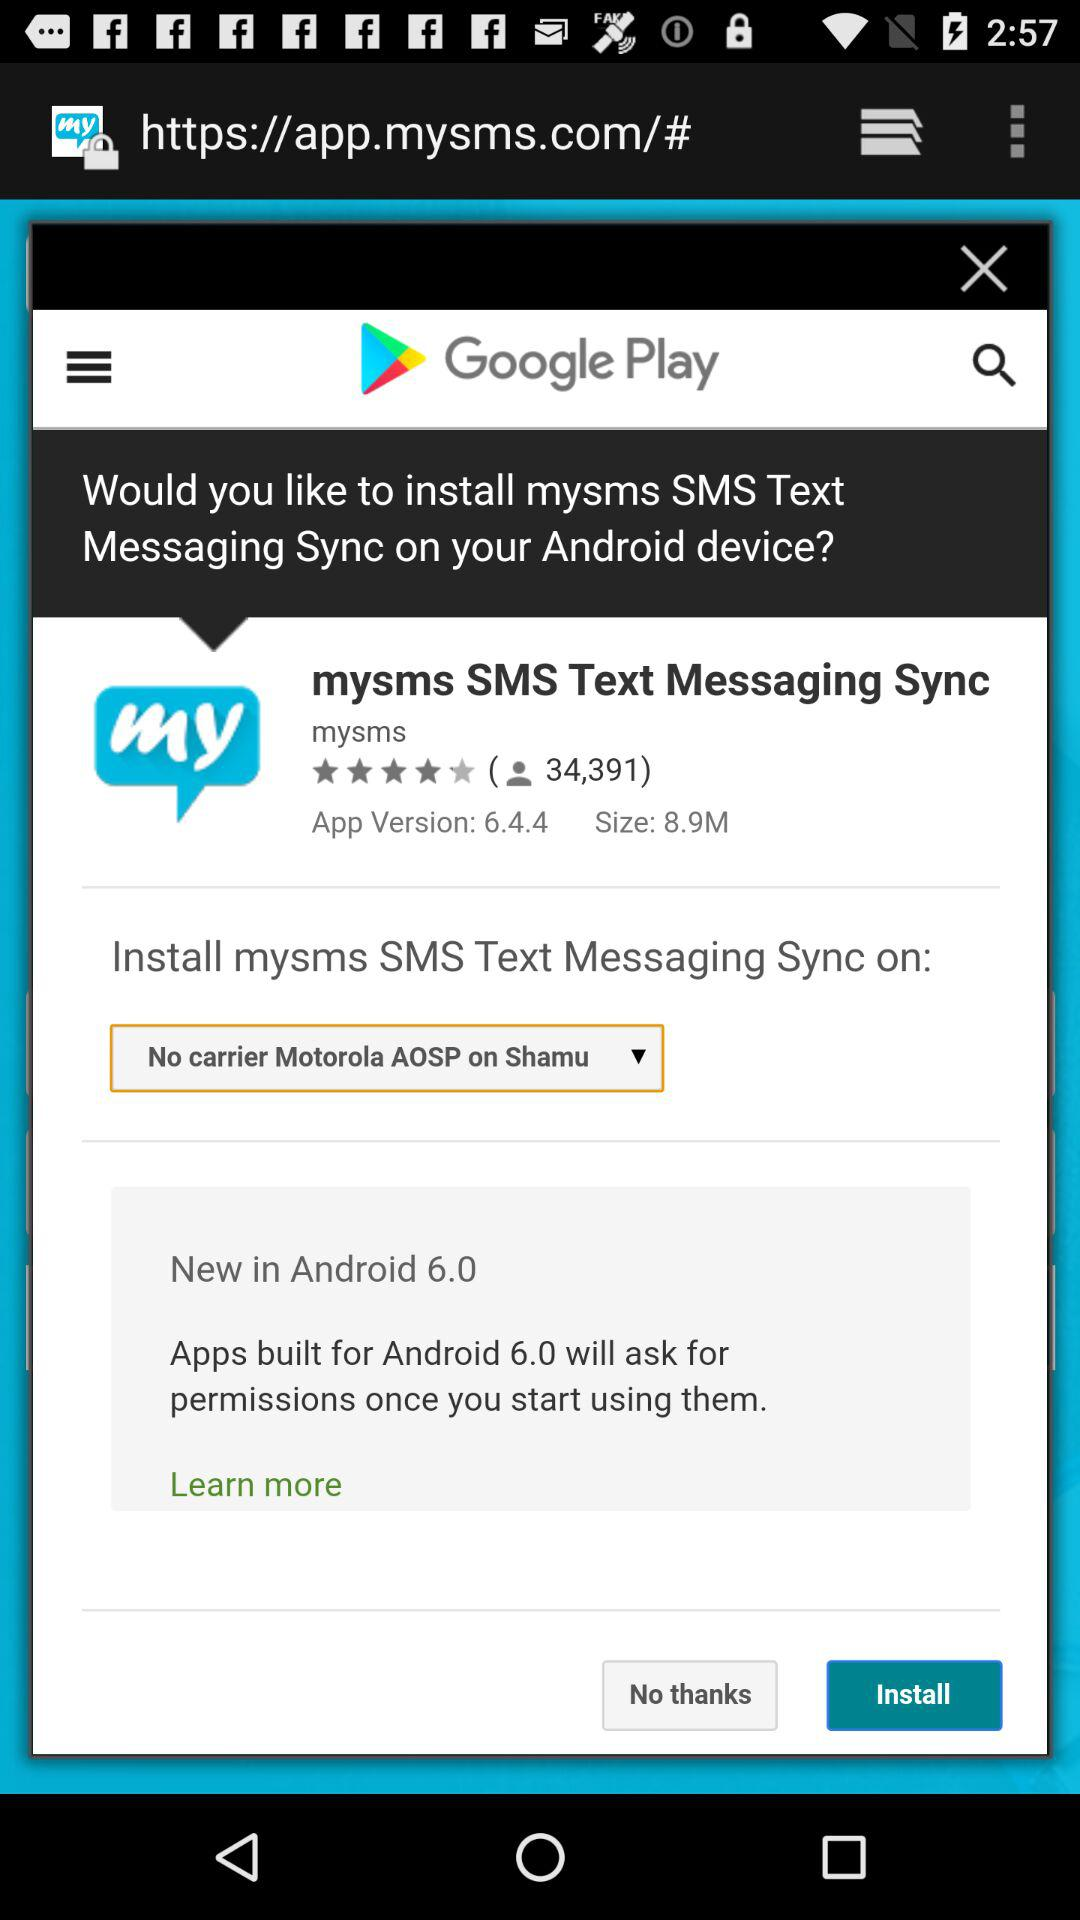What is the given rating? The rating is 4 stars. 